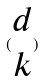<formula> <loc_0><loc_0><loc_500><loc_500>( \begin{matrix} d \\ k \end{matrix} )</formula> 